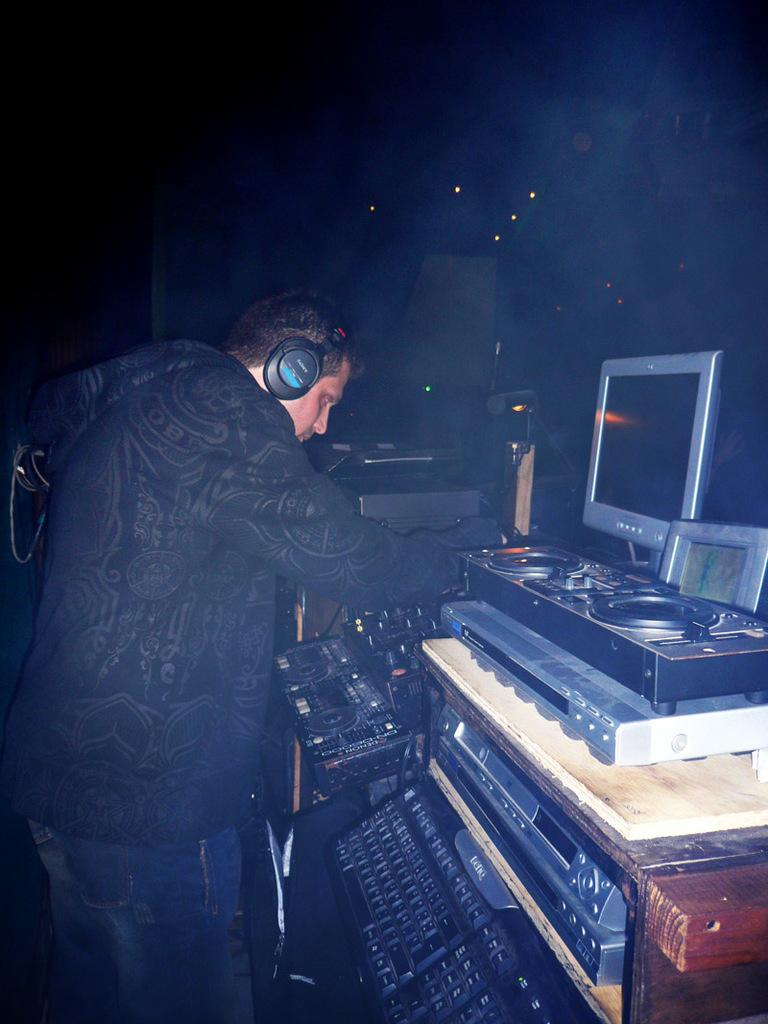What is the person in the image wearing on their head? The person in the image is wearing a headset. What can be seen in the background of the image? There are musical instruments in the background of the image. What is illuminating the scene in the image? There are lights visible in the image. What electronic device is present in the image? A: There is a laptop in the image. Can you see any steam coming from the yak in the image? There is no yak present in the image, so there is no steam to be seen. 